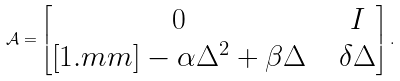<formula> <loc_0><loc_0><loc_500><loc_500>\mathcal { A } = \begin{bmatrix} 0 & & I \\ [ 1 . m m ] - \alpha \Delta ^ { 2 } + \beta \Delta & & \delta \Delta \end{bmatrix} .</formula> 